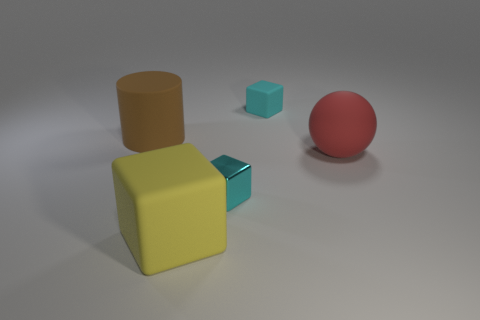What number of small metal cubes are the same color as the small matte cube?
Keep it short and to the point. 1. What is the shape of the yellow rubber object?
Provide a succinct answer. Cube. The big rubber thing that is both behind the yellow rubber thing and right of the big brown rubber object is what color?
Ensure brevity in your answer.  Red. What material is the big cylinder?
Provide a short and direct response. Rubber. There is a cyan thing in front of the red object; what is its shape?
Keep it short and to the point. Cube. There is a sphere that is the same size as the brown thing; what color is it?
Your answer should be compact. Red. Does the cyan block that is in front of the matte cylinder have the same material as the brown thing?
Give a very brief answer. No. There is a object that is both right of the big matte cube and to the left of the tiny cyan matte cube; what is its size?
Provide a succinct answer. Small. There is a matte cube in front of the brown matte cylinder; what is its size?
Offer a terse response. Large. There is a object that is behind the large object that is on the left side of the rubber cube to the left of the metal block; what shape is it?
Offer a very short reply. Cube. 